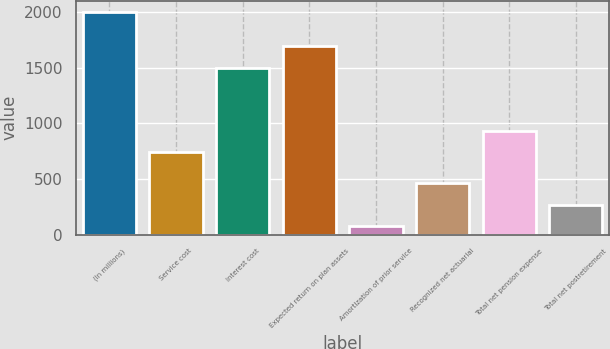<chart> <loc_0><loc_0><loc_500><loc_500><bar_chart><fcel>(In millions)<fcel>Service cost<fcel>Interest cost<fcel>Expected return on plan assets<fcel>Amortization of prior service<fcel>Recognized net actuarial<fcel>Total net pension expense<fcel>Total net postretirement<nl><fcel>2004<fcel>743<fcel>1497<fcel>1698<fcel>78<fcel>463.2<fcel>935.6<fcel>270.6<nl></chart> 